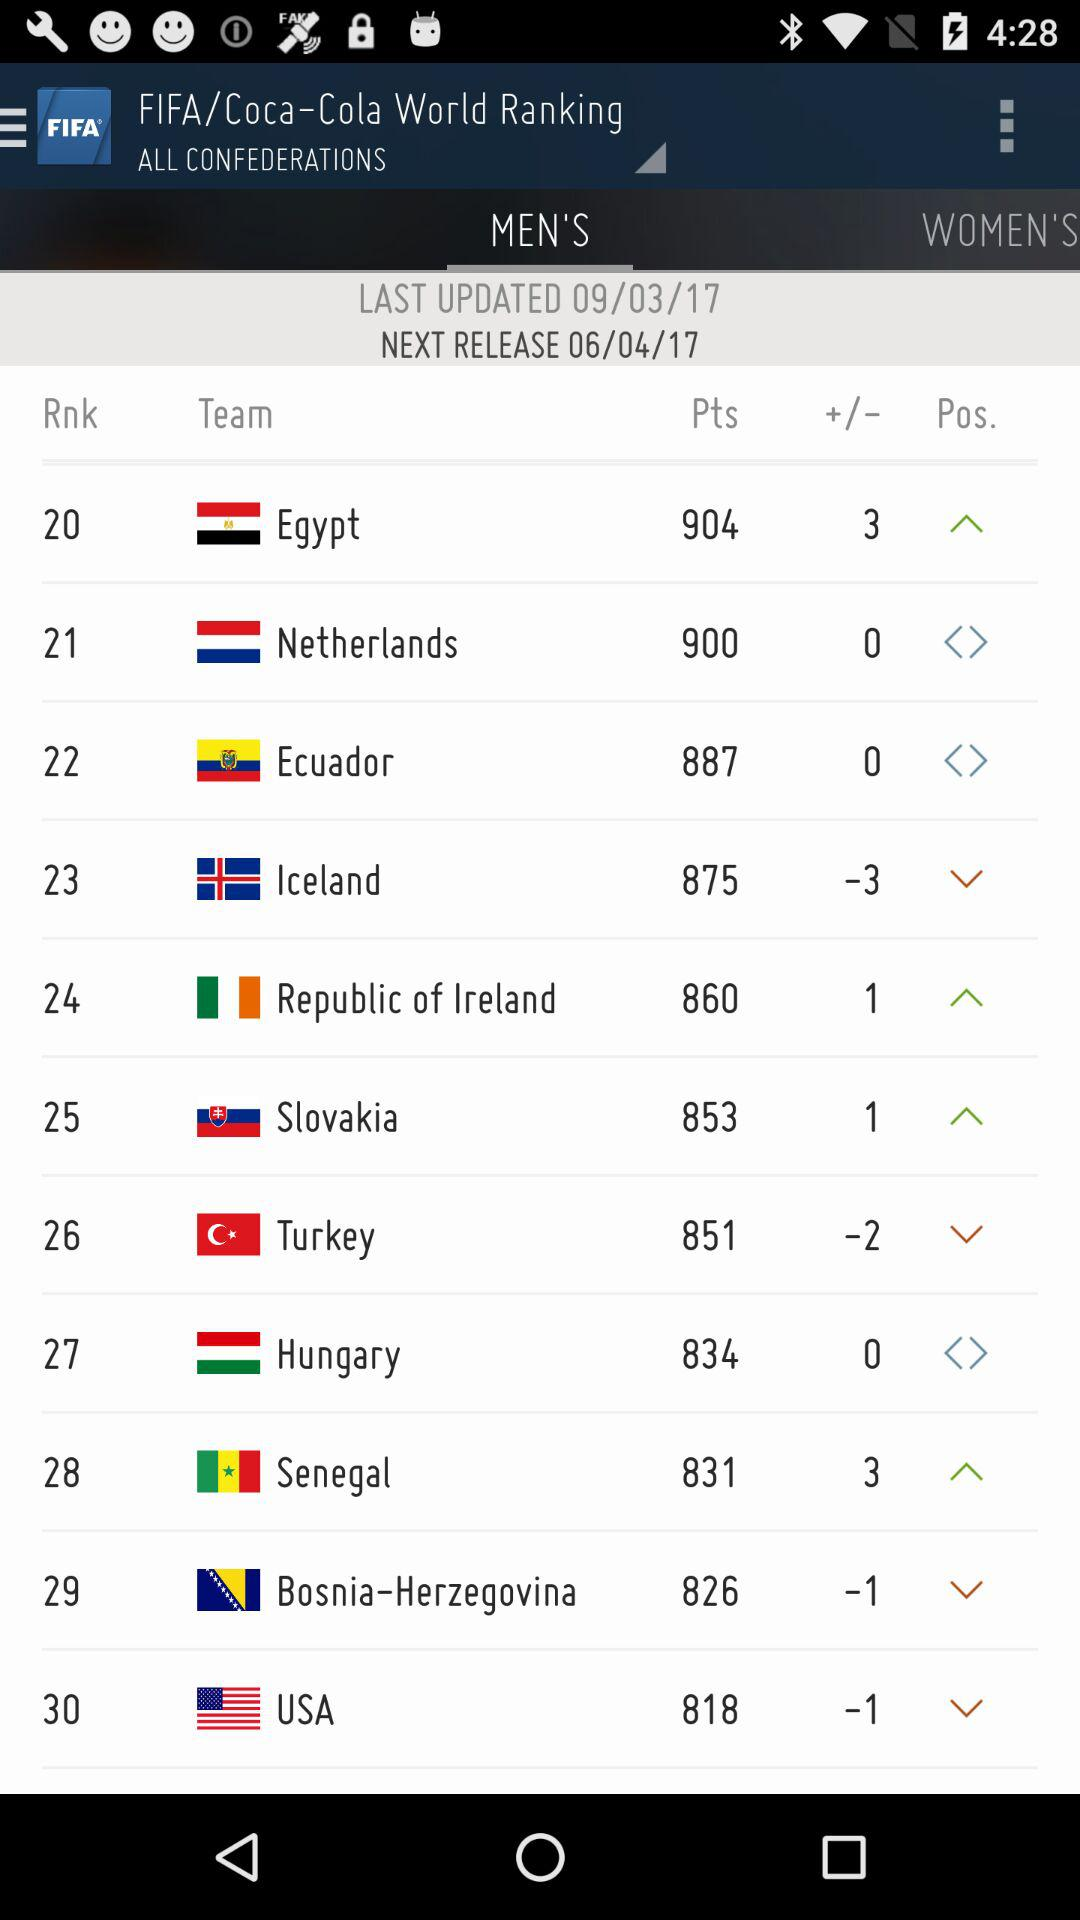Which team has the highest number of points?
Answer the question using a single word or phrase. Egypt 